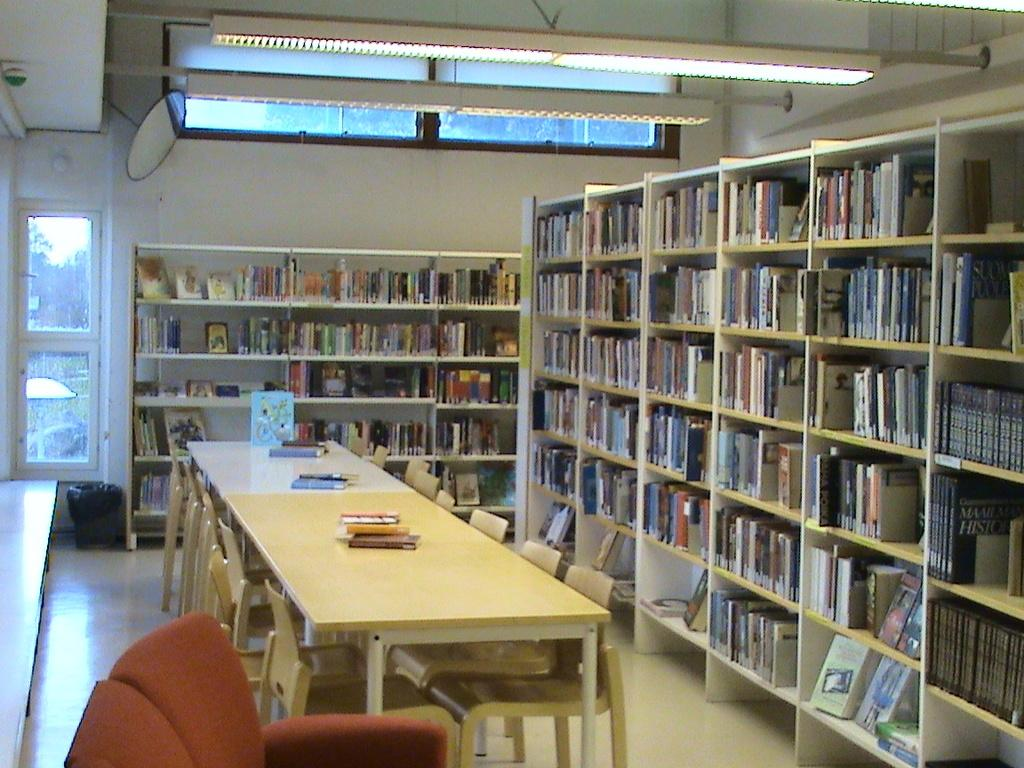<image>
Offer a succinct explanation of the picture presented. A library filled with books, including a white covered book face up with only the letter C on it. 